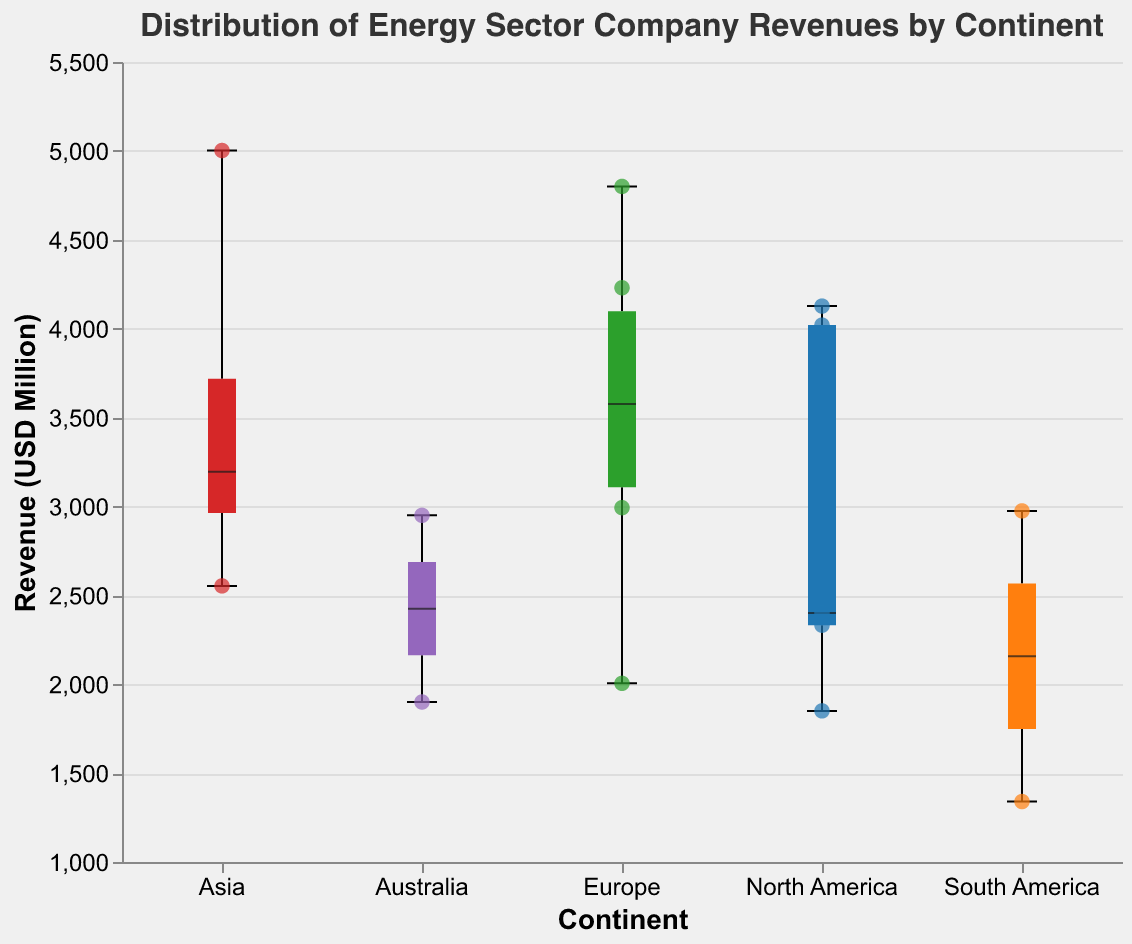What is the title of the figure? The title of the figure is displayed at the top of the chart in larger font size. It states the main subject of the visualization.
Answer: Distribution of Energy Sector Company Revenues by Continent How many continents are represented in the figure? By looking at the x-axis, which categorizes the data by continent, we can count the distinct labels.
Answer: 5 Which continent has the highest individual company revenue, and what is that value? The scatter points show individual company revenues. By inspecting the points, the highest scatter point is in Asia. The tooltip will help confirm the specific value.
Answer: Asia, 5002 Which continent shows the widest range of revenues, and what are the minimum and maximum values? The range can be assessed by looking at the extents of the box plots. The widest range will have the largest gap between the minimum and maximum values. Europe shows this with its minimum around 2000 and maximum around 4800.
Answer: Europe, min: 2005, max: 4800 What is the median revenue for energy companies in North America? The median value is represented by the thick line inside the box plot for North America.
Answer: Approximately 3120 What is the revenue of ExxonMobil in North America? The scatter points represent individual company revenues, and by hovering over the point labeled "ExxonMobil" on the plot for North America, we can see the revenue.
Answer: 4127 How many companies in Europe have revenues highlighted as scatter points? Each scatter point represents an individual company. By counting the points within the Europe category, we determine the number of companies.
Answer: 6 Which continent has the lowest median revenue and what is that value? The median is the middle line within each box plot. By comparing these lines across all continents, South America has the lowest median.
Answer: South America, approximately 2157.5 Compare the interquartile range (IQR) of North America and Australia. Which one is larger? The IQR is represented by the height of the box itself. North America's box appears taller compared to Australia's, indicating a larger IQR.
Answer: North America Are there any outliers in the revenue data for Europe? If so, what are they? Outliers would typically be shown as individual points outside the whiskers of the box plot. By identifying points beyond the extent of the box plot in Europe, specifically the scatter points, we confirm their presence.
Answer: Yes, Gazprom's 4800 and Royal Dutch Shell's 4230 among others 